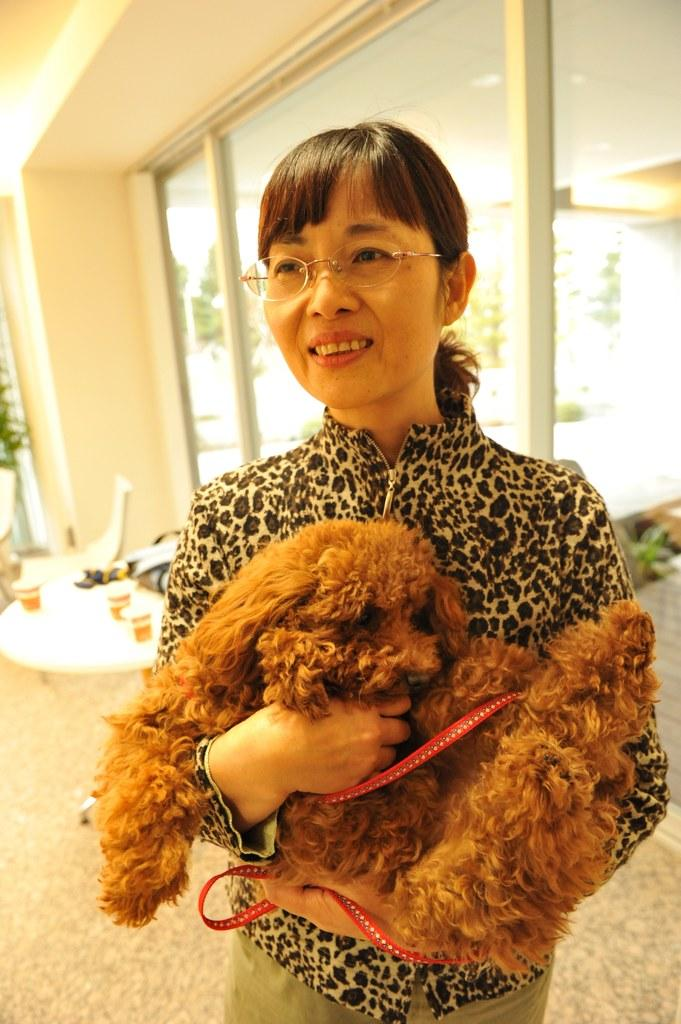Who is the main subject in the image? There is a woman in the image. What is the woman holding in the image? The woman is holding a dog. Can you describe the woman's appearance? The woman is wearing spectacles. What can be seen in the background of the image? There is a table and chairs in the background of the image. What type of pail is the governor using to sleep in the image? There is no governor, pail, or sleeping depicted in the image. 